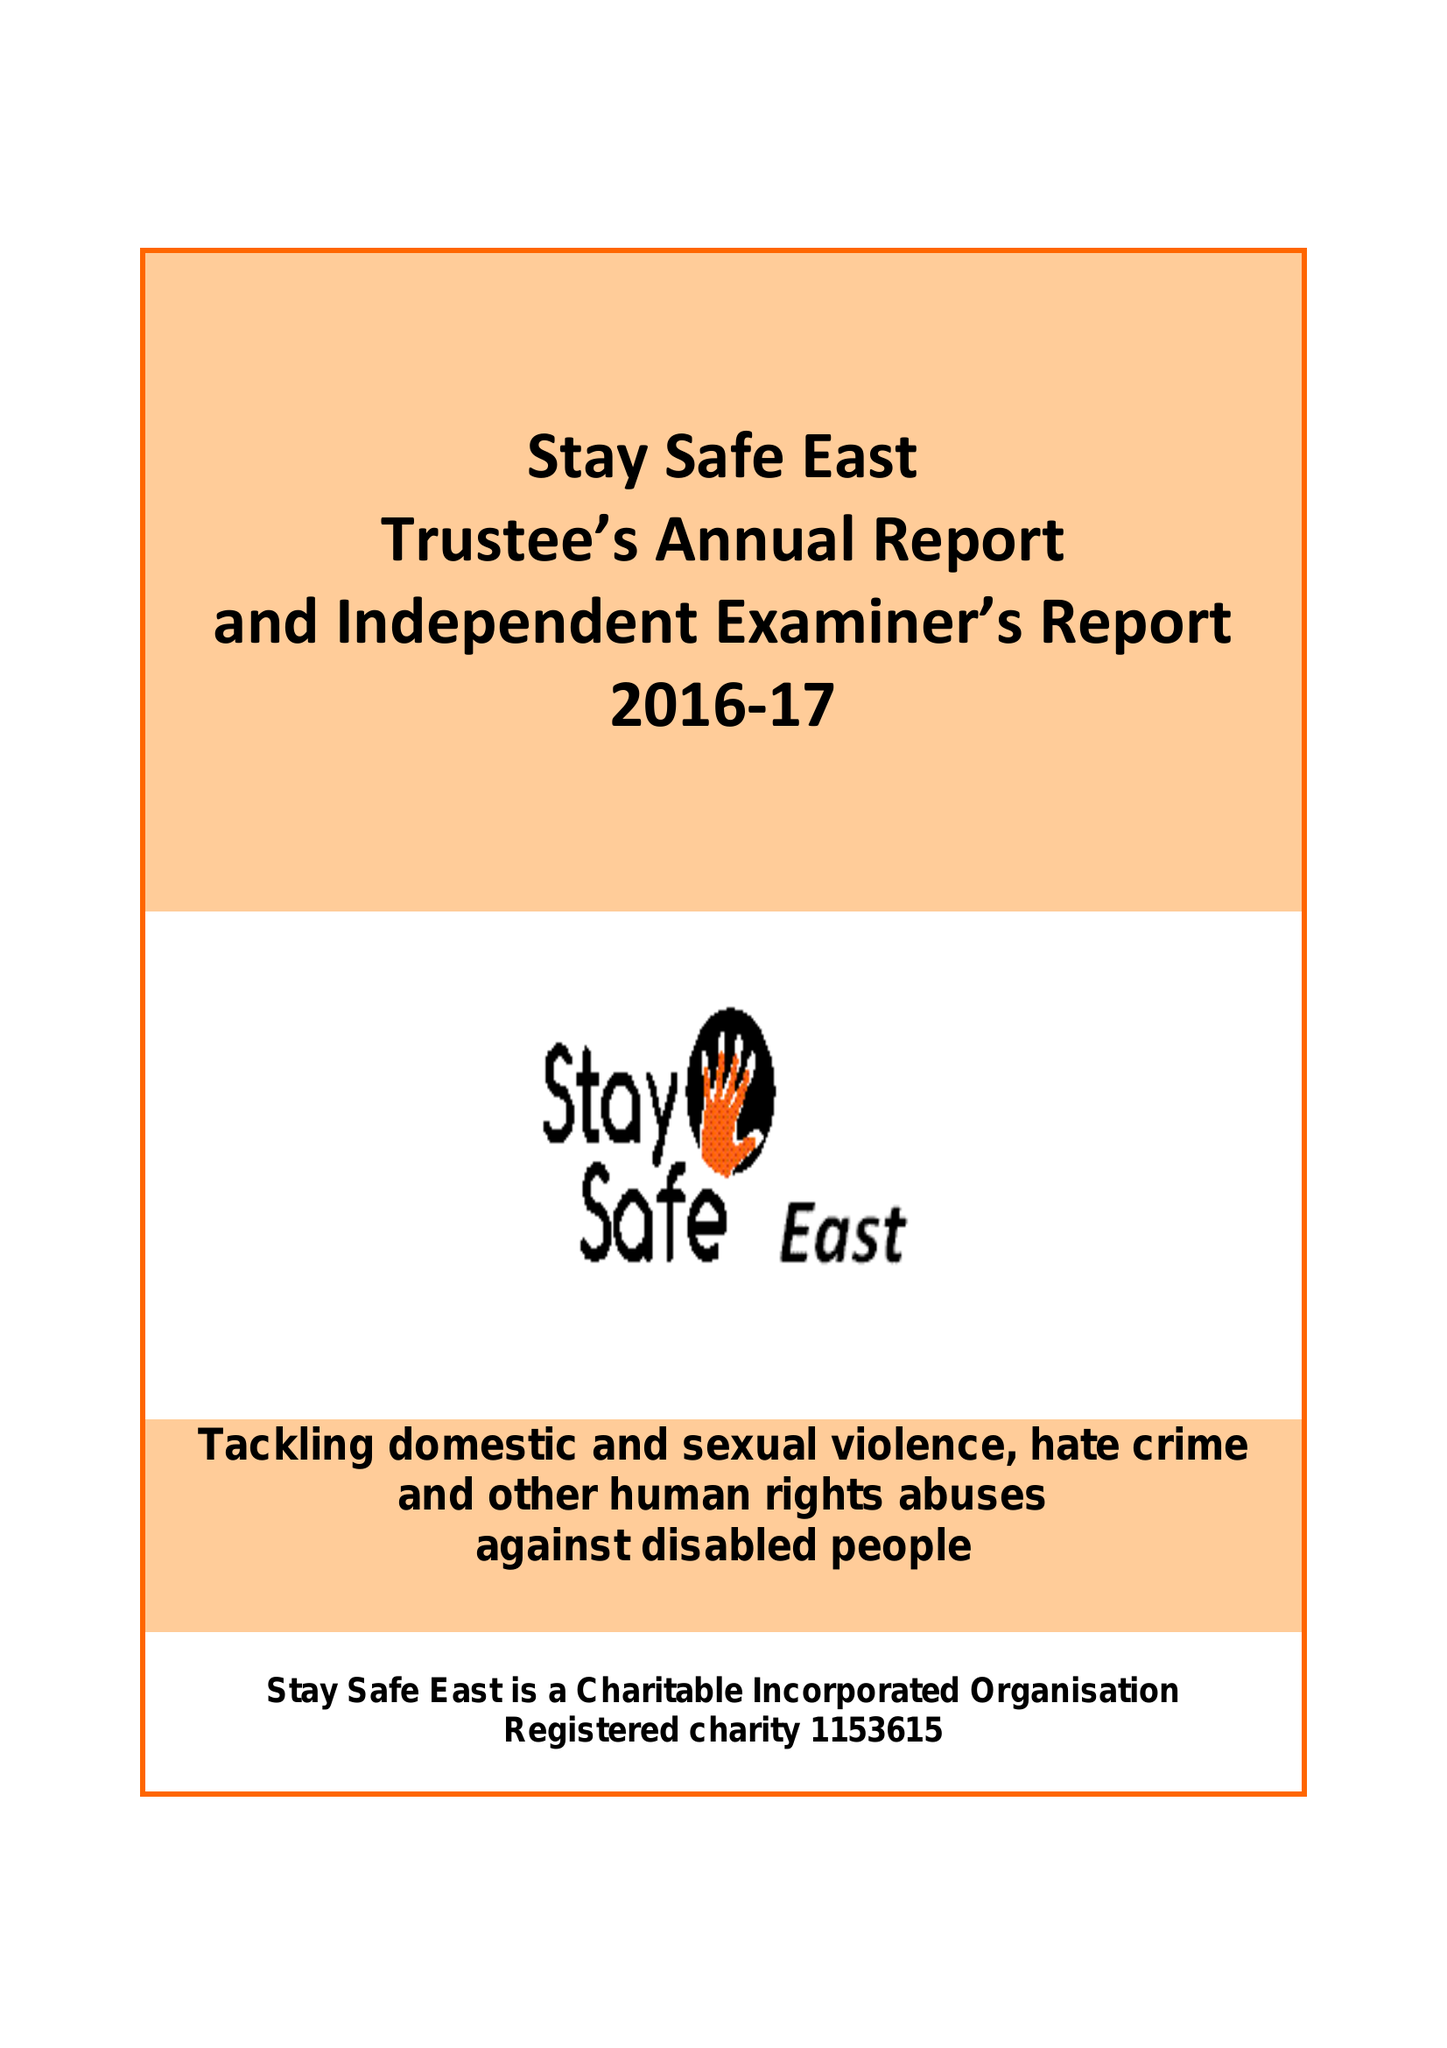What is the value for the address__post_town?
Answer the question using a single word or phrase. LONDON 